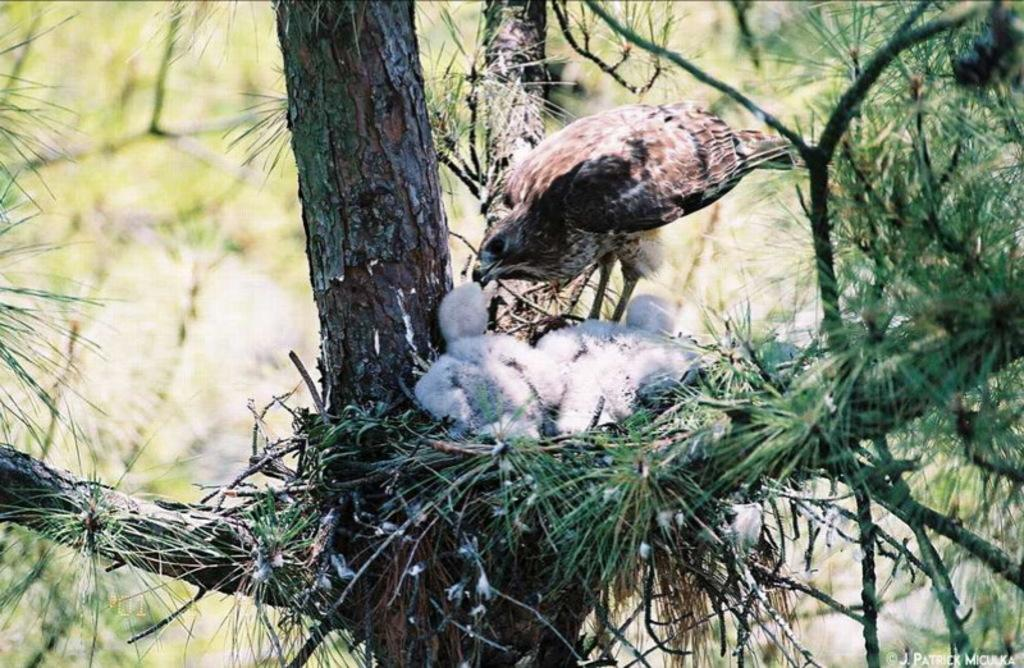What type of animal is in the image? There is a bird in the image. Where is the bird located? The bird is on a tree. What can be inferred about the weather or season from the image? The image appears to depict a snowy scene. What is visible in the background of the image? There are trees in the background of the image. What route does the bird take to reach its nest in the image? There is no information about the bird's nest or its route in the image. 